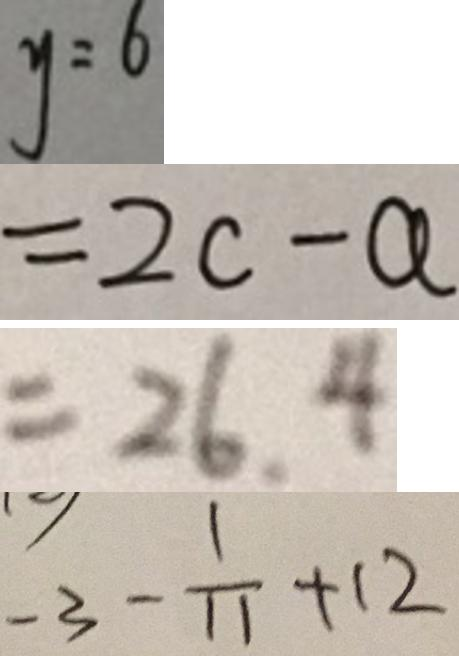Convert formula to latex. <formula><loc_0><loc_0><loc_500><loc_500>y = 6 
 = 2 c - a 
 = 2 6 . 4 
 - 3 - \frac { 1 } { 1 1 } + 1 2</formula> 